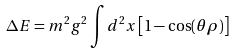Convert formula to latex. <formula><loc_0><loc_0><loc_500><loc_500>\Delta E = m ^ { 2 } g ^ { 2 } \int d ^ { 2 } x \left [ 1 - \cos ( \theta \rho ) \right ]</formula> 